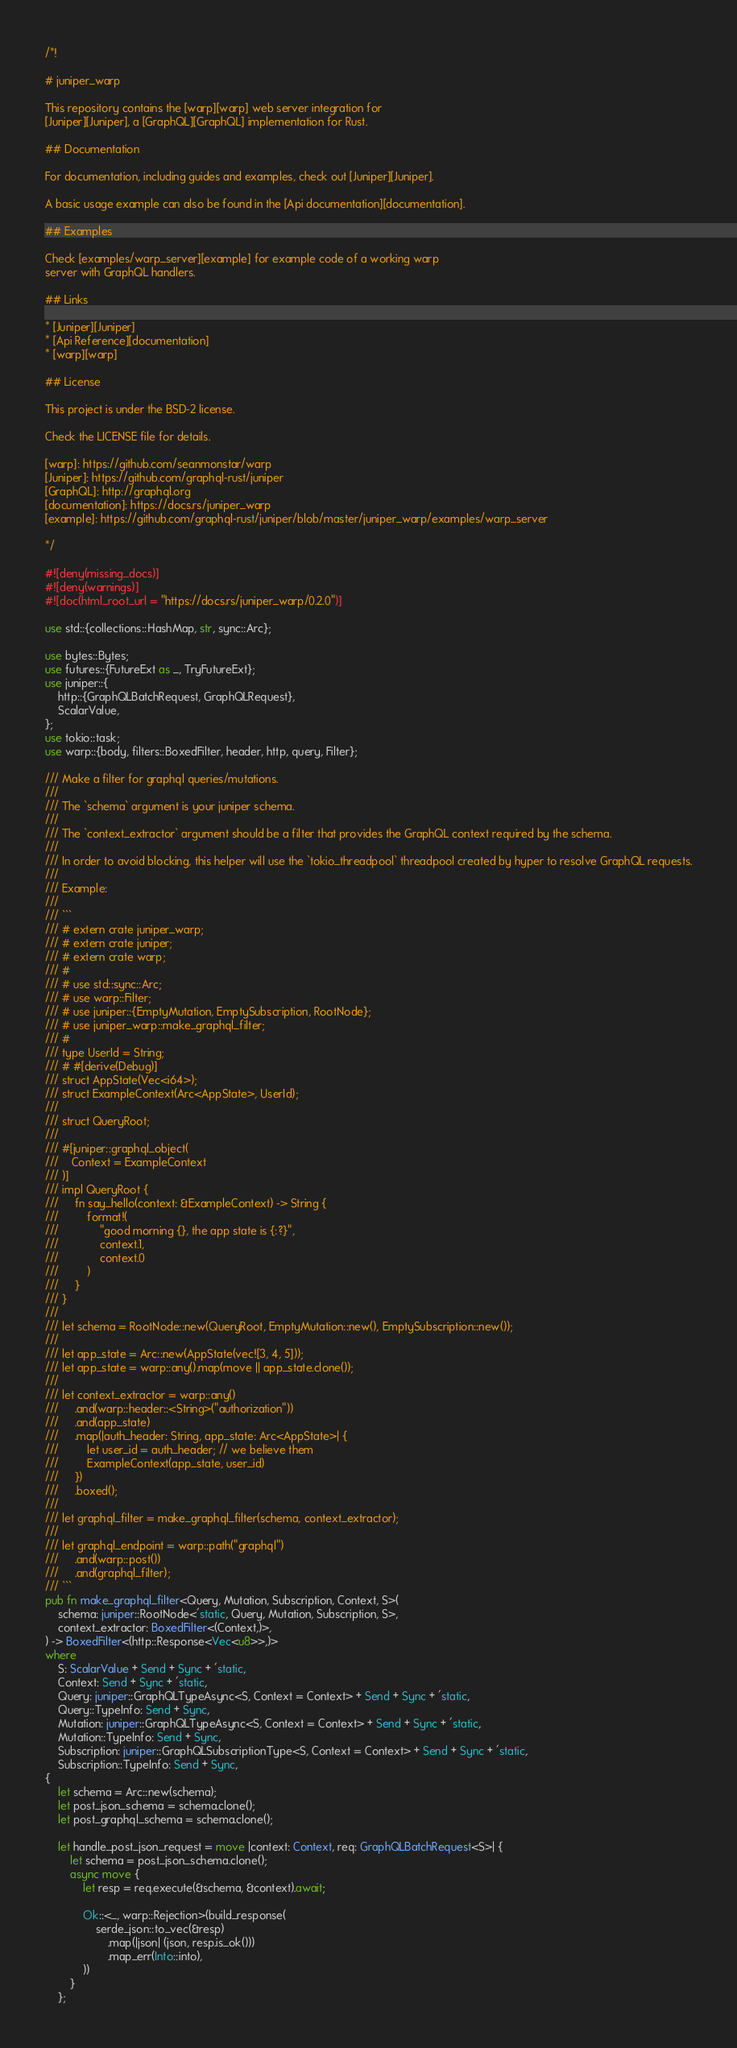Convert code to text. <code><loc_0><loc_0><loc_500><loc_500><_Rust_>/*!

# juniper_warp

This repository contains the [warp][warp] web server integration for
[Juniper][Juniper], a [GraphQL][GraphQL] implementation for Rust.

## Documentation

For documentation, including guides and examples, check out [Juniper][Juniper].

A basic usage example can also be found in the [Api documentation][documentation].

## Examples

Check [examples/warp_server][example] for example code of a working warp
server with GraphQL handlers.

## Links

* [Juniper][Juniper]
* [Api Reference][documentation]
* [warp][warp]

## License

This project is under the BSD-2 license.

Check the LICENSE file for details.

[warp]: https://github.com/seanmonstar/warp
[Juniper]: https://github.com/graphql-rust/juniper
[GraphQL]: http://graphql.org
[documentation]: https://docs.rs/juniper_warp
[example]: https://github.com/graphql-rust/juniper/blob/master/juniper_warp/examples/warp_server

*/

#![deny(missing_docs)]
#![deny(warnings)]
#![doc(html_root_url = "https://docs.rs/juniper_warp/0.2.0")]

use std::{collections::HashMap, str, sync::Arc};

use bytes::Bytes;
use futures::{FutureExt as _, TryFutureExt};
use juniper::{
    http::{GraphQLBatchRequest, GraphQLRequest},
    ScalarValue,
};
use tokio::task;
use warp::{body, filters::BoxedFilter, header, http, query, Filter};

/// Make a filter for graphql queries/mutations.
///
/// The `schema` argument is your juniper schema.
///
/// The `context_extractor` argument should be a filter that provides the GraphQL context required by the schema.
///
/// In order to avoid blocking, this helper will use the `tokio_threadpool` threadpool created by hyper to resolve GraphQL requests.
///
/// Example:
///
/// ```
/// # extern crate juniper_warp;
/// # extern crate juniper;
/// # extern crate warp;
/// #
/// # use std::sync::Arc;
/// # use warp::Filter;
/// # use juniper::{EmptyMutation, EmptySubscription, RootNode};
/// # use juniper_warp::make_graphql_filter;
/// #
/// type UserId = String;
/// # #[derive(Debug)]
/// struct AppState(Vec<i64>);
/// struct ExampleContext(Arc<AppState>, UserId);
///
/// struct QueryRoot;
///
/// #[juniper::graphql_object(
///    Context = ExampleContext
/// )]
/// impl QueryRoot {
///     fn say_hello(context: &ExampleContext) -> String {
///         format!(
///             "good morning {}, the app state is {:?}",
///             context.1,
///             context.0
///         )
///     }
/// }
///
/// let schema = RootNode::new(QueryRoot, EmptyMutation::new(), EmptySubscription::new());
///
/// let app_state = Arc::new(AppState(vec![3, 4, 5]));
/// let app_state = warp::any().map(move || app_state.clone());
///
/// let context_extractor = warp::any()
///     .and(warp::header::<String>("authorization"))
///     .and(app_state)
///     .map(|auth_header: String, app_state: Arc<AppState>| {
///         let user_id = auth_header; // we believe them
///         ExampleContext(app_state, user_id)
///     })
///     .boxed();
///
/// let graphql_filter = make_graphql_filter(schema, context_extractor);
///
/// let graphql_endpoint = warp::path("graphql")
///     .and(warp::post())
///     .and(graphql_filter);
/// ```
pub fn make_graphql_filter<Query, Mutation, Subscription, Context, S>(
    schema: juniper::RootNode<'static, Query, Mutation, Subscription, S>,
    context_extractor: BoxedFilter<(Context,)>,
) -> BoxedFilter<(http::Response<Vec<u8>>,)>
where
    S: ScalarValue + Send + Sync + 'static,
    Context: Send + Sync + 'static,
    Query: juniper::GraphQLTypeAsync<S, Context = Context> + Send + Sync + 'static,
    Query::TypeInfo: Send + Sync,
    Mutation: juniper::GraphQLTypeAsync<S, Context = Context> + Send + Sync + 'static,
    Mutation::TypeInfo: Send + Sync,
    Subscription: juniper::GraphQLSubscriptionType<S, Context = Context> + Send + Sync + 'static,
    Subscription::TypeInfo: Send + Sync,
{
    let schema = Arc::new(schema);
    let post_json_schema = schema.clone();
    let post_graphql_schema = schema.clone();

    let handle_post_json_request = move |context: Context, req: GraphQLBatchRequest<S>| {
        let schema = post_json_schema.clone();
        async move {
            let resp = req.execute(&schema, &context).await;

            Ok::<_, warp::Rejection>(build_response(
                serde_json::to_vec(&resp)
                    .map(|json| (json, resp.is_ok()))
                    .map_err(Into::into),
            ))
        }
    };</code> 